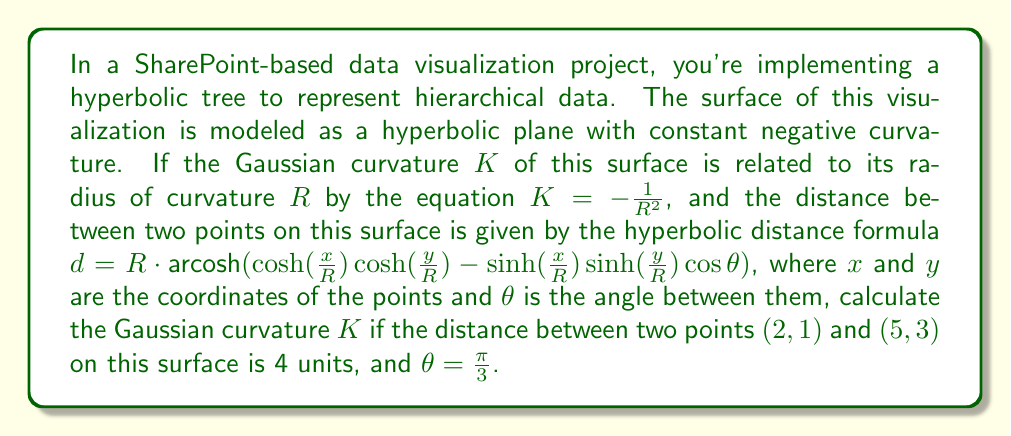Can you solve this math problem? To solve this problem, we'll follow these steps:

1) We're given the hyperbolic distance formula:
   $$d = R \cdot \text{arcosh}(\cosh(\frac{x}{R})\cosh(\frac{y}{R}) - \sinh(\frac{x}{R})\sinh(\frac{y}{R})\cos\theta)$$

2) We know $d = 4$, $(x_1,y_1) = (2,1)$, $(x_2,y_2) = (5,3)$, and $\theta = \frac{\pi}{3}$

3) Substituting these values:
   $$4 = R \cdot \text{arcosh}(\cosh(\frac{5-2}{R})\cosh(\frac{3-1}{R}) - \sinh(\frac{5-2}{R})\sinh(\frac{3-1}{R})\cos(\frac{\pi}{3}))$$

4) Simplify:
   $$4 = R \cdot \text{arcosh}(\cosh(\frac{3}{R})\cosh(\frac{2}{R}) - \sinh(\frac{3}{R})\sinh(\frac{2}{R})\cdot\frac{1}{2})$$

5) This equation can be solved numerically to find $R \approx 1.822687$

6) Now we can use the relation $K = -\frac{1}{R^2}$:
   $$K = -\frac{1}{(1.822687)^2} \approx -0.301105$$

Therefore, the Gaussian curvature $K$ of the hyperbolic surface is approximately -0.301105.
Answer: $K \approx -0.301105$ 